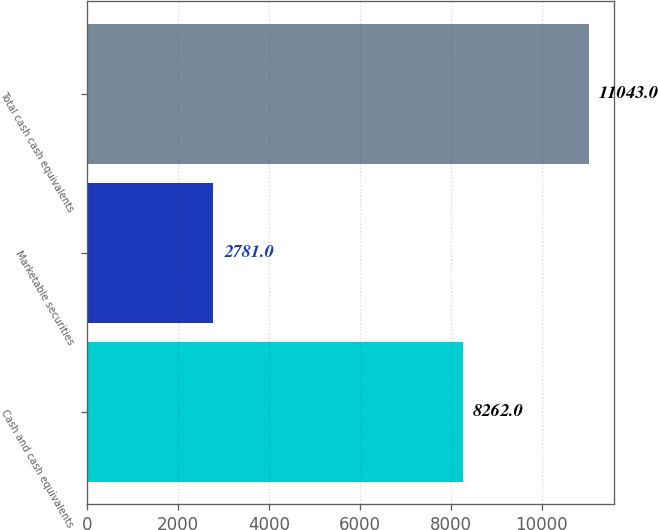Convert chart. <chart><loc_0><loc_0><loc_500><loc_500><bar_chart><fcel>Cash and cash equivalents<fcel>Marketable securities<fcel>Total cash cash equivalents<nl><fcel>8262<fcel>2781<fcel>11043<nl></chart> 